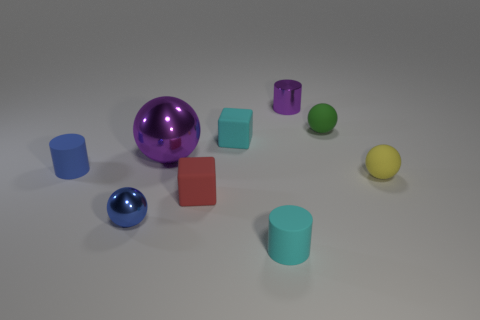Is the big metallic sphere the same color as the metal cylinder?
Give a very brief answer. Yes. The thing that is the same color as the metallic cylinder is what size?
Provide a succinct answer. Large. There is a rubber sphere in front of the cyan object behind the blue ball; what is its color?
Make the answer very short. Yellow. Are the cyan cylinder and the ball to the left of the purple shiny sphere made of the same material?
Ensure brevity in your answer.  No. What material is the purple object to the left of the tiny red cube?
Your answer should be very brief. Metal. Is the number of purple metallic cylinders in front of the blue shiny thing the same as the number of tiny yellow shiny objects?
Provide a short and direct response. Yes. Are there any other things that are the same size as the purple shiny ball?
Offer a terse response. No. The cyan thing that is left of the rubber cylinder that is right of the red block is made of what material?
Give a very brief answer. Rubber. The shiny object that is behind the tiny blue sphere and on the left side of the cyan block has what shape?
Give a very brief answer. Sphere. There is a purple thing that is the same shape as the tiny green matte thing; what is its size?
Provide a succinct answer. Large. 